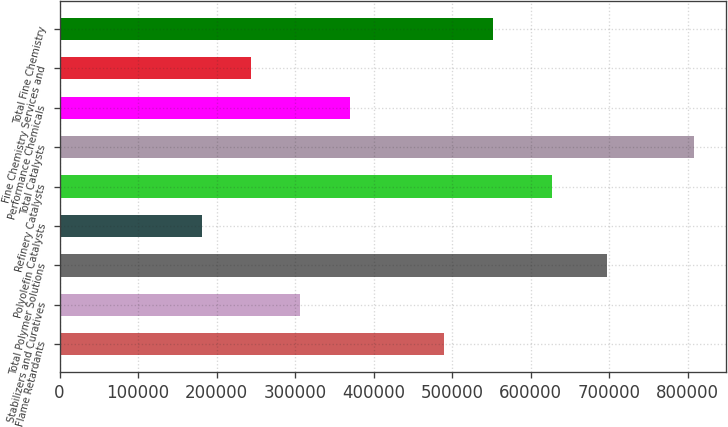Convert chart. <chart><loc_0><loc_0><loc_500><loc_500><bar_chart><fcel>Flame Retardants<fcel>Stabilizers and Curatives<fcel>Total Polymer Solutions<fcel>Polyolefin Catalysts<fcel>Refinery Catalysts<fcel>Total Catalysts<fcel>Performance Chemicals<fcel>Fine Chemistry Services and<fcel>Total Fine Chemistry<nl><fcel>489484<fcel>306737<fcel>697206<fcel>181406<fcel>626657<fcel>808063<fcel>369403<fcel>244072<fcel>552150<nl></chart> 